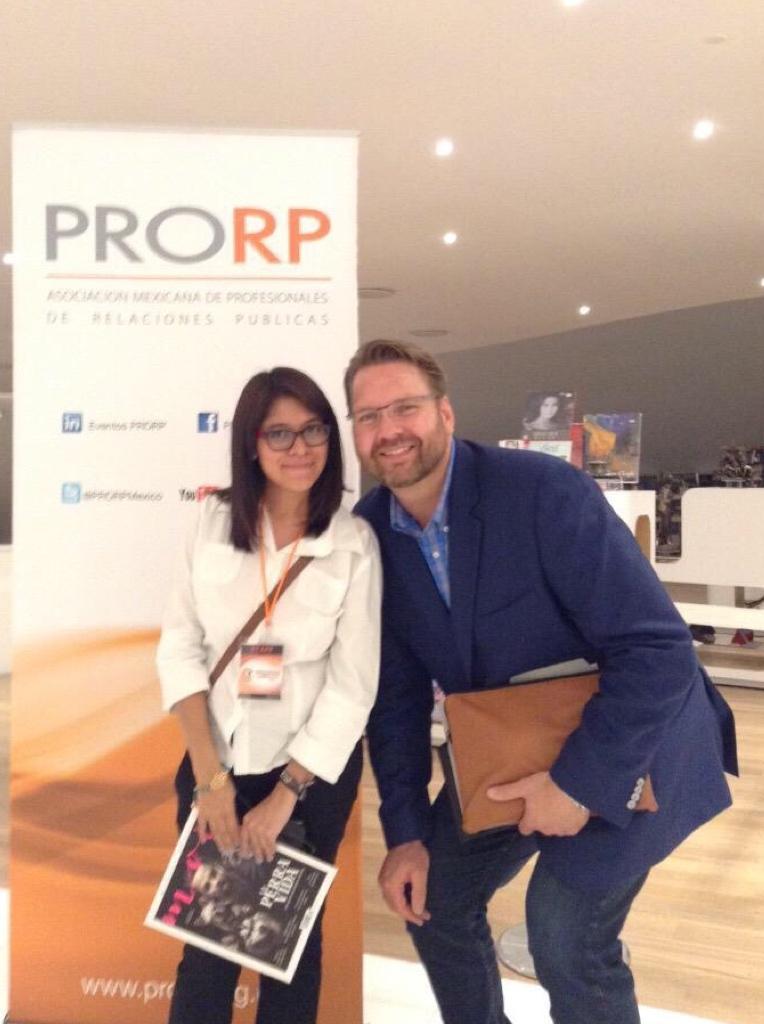Please provide a concise description of this image. In this image there are two persons standing and smiling by holding books, and in the background there are boards, lights. 